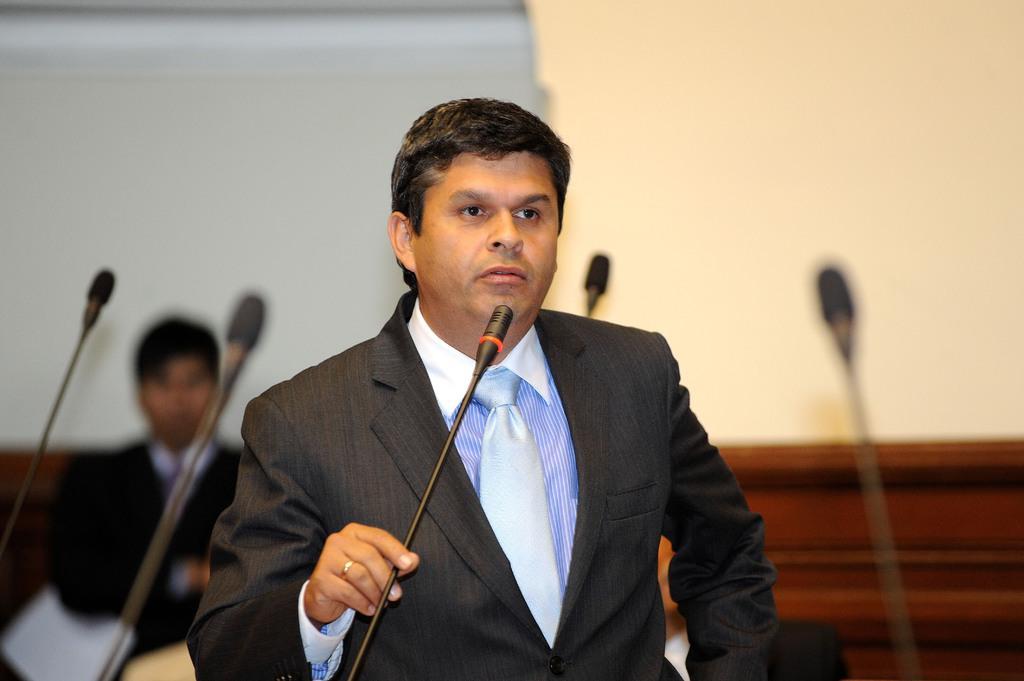Could you give a brief overview of what you see in this image? In this image there is a person standing and talking and he is holding a microphone. At the back there are microphones. There is a person standing at the back and holding a paper. 